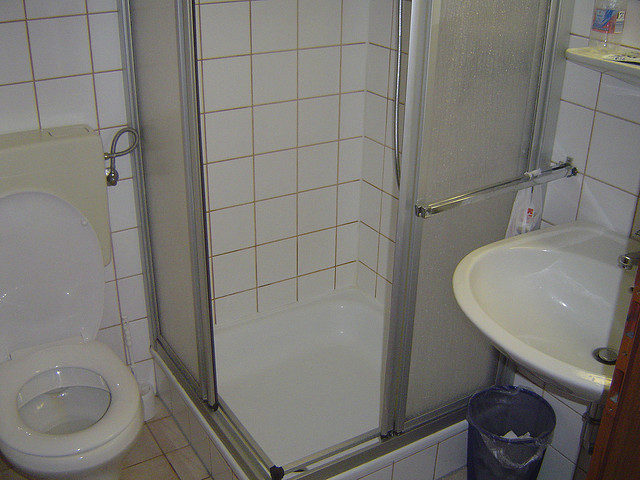Plunge into a creative narrative involving the bathroom's inanimate objects. In the still silence of midnight, the bathroom comes alive in a story untold to the waking world. The toilet, Sir Flushington, stands noble and wise, ever vigilant in its duty. The sink, known to the others as Lady Fresh, sparkles with pride, having washed away countless worries and grime. Every evening, as the household sleeps, Sir Flushington shares tales from the day while Lady Fresh recounts the myriad faces it has seen. The shower, The Cleanse Duke, splashes with enthusiasm, eager to rid the world of dirt and bring purity. The humble wastebasket isn't left out; it boasts of holding secrets and forgotten notes, a custodian of lore whispered behind closed doors. And the bottle on the shelf, The Elixir Keeper, watches over them all, its contents a magical potion for the weary and unkempt. Together, they weave a narrative of unwavering camaraderie, bound by purpose in their tight yet functional kingdom. Imagine this bathroom in a different scenario, like a luxurious hotel bathroom. How would it look and feel? In a luxurious hotel setting, the bathroom would undergo a remarkable transformation. The toilet would be ultra-modern, with an automated flush system, heated seat, and bidet functionality. The shower cubicle would be replaced with a lavish walk-in shower, adorned with rain showerheads, body jets, and mosaic tiles in hues of blue and gold. The sink would be a stylish, double-basin affair, carved from pristine marble with sleek, high-end fixtures. The walls would be lined with elegant tiles, creating a tranquil and opulent atmosphere. A large, backlit mirror would add a sense of space and grandeur, while soft ambient lighting would cast a serene glow. Plush towels, high-quality toiletries, and a sense of pristine cleanliness would make this bathroom a sanctuary of luxury and comfort. 